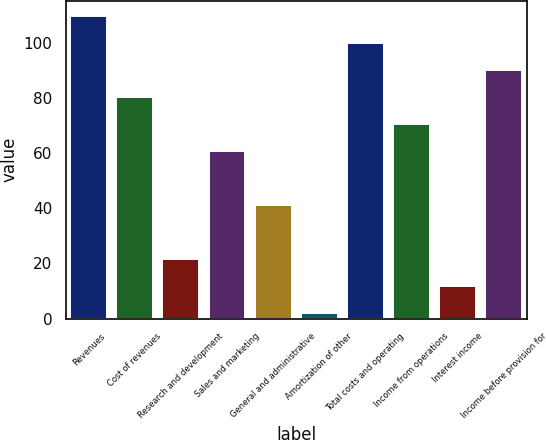Convert chart. <chart><loc_0><loc_0><loc_500><loc_500><bar_chart><fcel>Revenues<fcel>Cost of revenues<fcel>Research and development<fcel>Sales and marketing<fcel>General and administrative<fcel>Amortization of other<fcel>Total costs and operating<fcel>Income from operations<fcel>Interest income<fcel>Income before provision for<nl><fcel>109.8<fcel>80.4<fcel>21.6<fcel>60.8<fcel>41.2<fcel>2<fcel>100<fcel>70.6<fcel>11.8<fcel>90.2<nl></chart> 